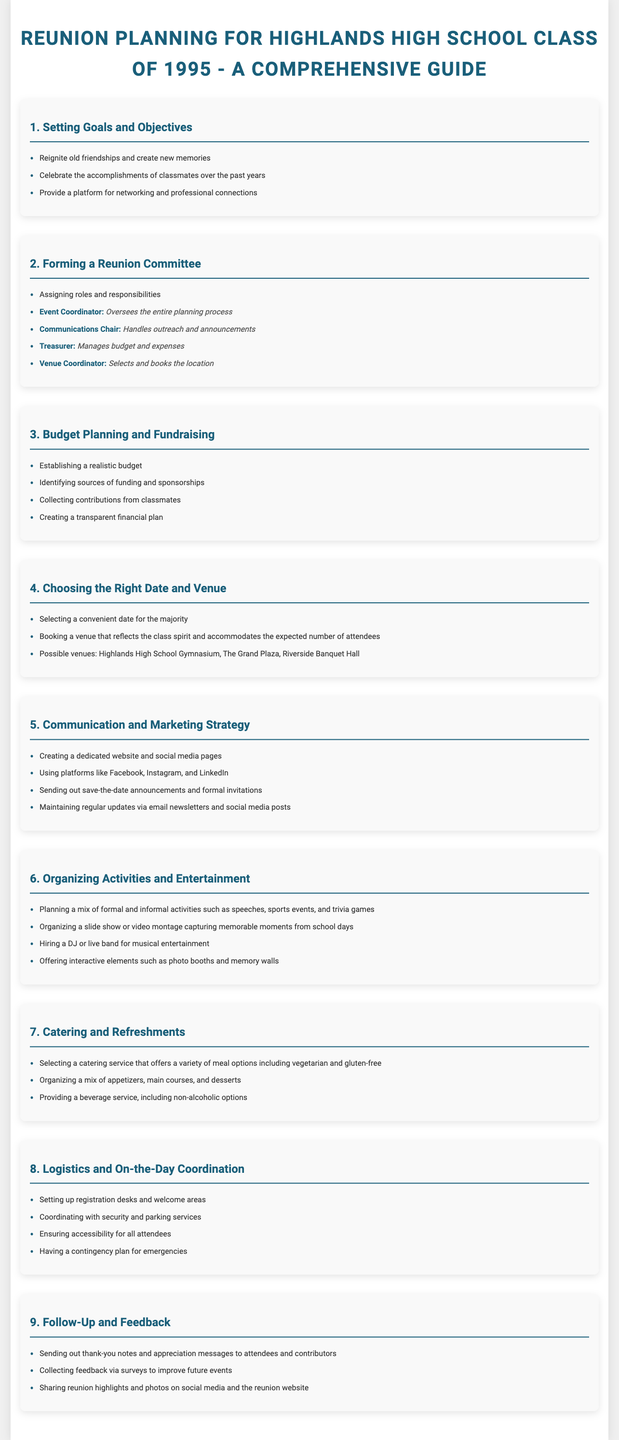What is the primary goal of the reunion? The primary goal is to reignite old friendships and create new memories.
Answer: Reignite old friendships and create new memories Who is responsible for overseeing the entire planning process? The role responsible for overseeing the planning process is the Event Coordinator.
Answer: Event Coordinator What is one task of the Communications Chair? One task is to handle outreach and announcements.
Answer: Handles outreach and announcements Name one venue option for the reunion. One option for the venue is The Grand Plaza.
Answer: The Grand Plaza What should follow up after the reunion? Sending out thank-you notes and appreciation messages to attendees.
Answer: Sending out thank-you notes How many key areas are outlined in the planning guide? There are nine key areas outlined in the planning guide.
Answer: Nine What is a suggested method for collecting feedback after the event? A suggested method is through surveys.
Answer: Surveys What entertainment option is recommended for the reunion? Hiring a DJ or live band for musical entertainment is recommended.
Answer: DJ or live band What is the role of the Treasurer? The role of the Treasurer is to manage budget and expenses.
Answer: Manages budget and expenses 